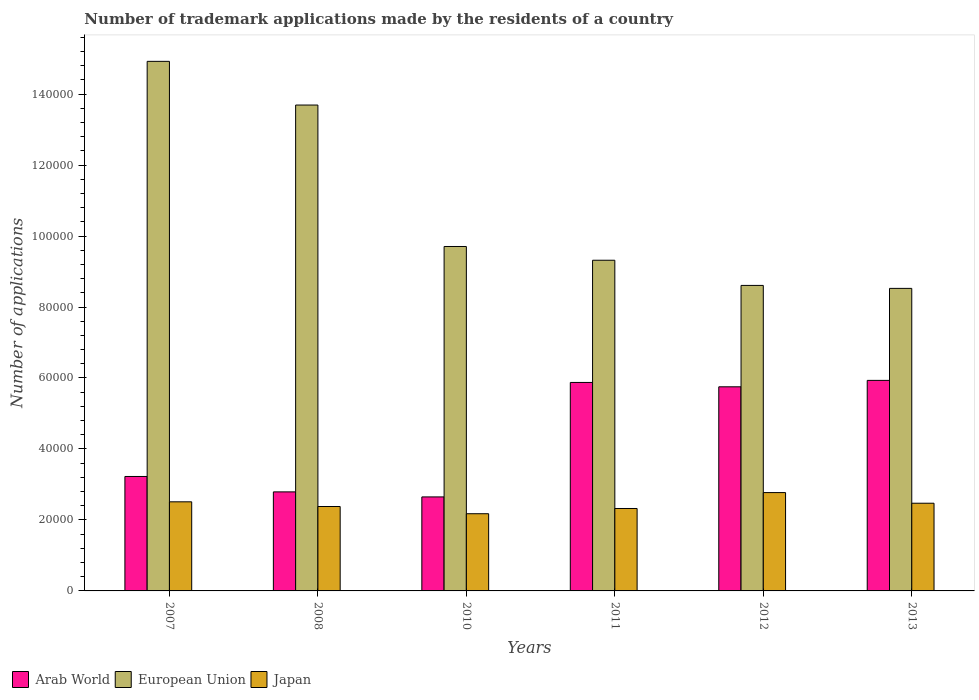How many different coloured bars are there?
Offer a terse response. 3. Are the number of bars per tick equal to the number of legend labels?
Provide a short and direct response. Yes. Are the number of bars on each tick of the X-axis equal?
Give a very brief answer. Yes. What is the label of the 3rd group of bars from the left?
Provide a short and direct response. 2010. What is the number of trademark applications made by the residents in European Union in 2012?
Your response must be concise. 8.61e+04. Across all years, what is the maximum number of trademark applications made by the residents in Arab World?
Your response must be concise. 5.93e+04. Across all years, what is the minimum number of trademark applications made by the residents in Japan?
Provide a succinct answer. 2.18e+04. In which year was the number of trademark applications made by the residents in European Union minimum?
Ensure brevity in your answer.  2013. What is the total number of trademark applications made by the residents in Arab World in the graph?
Offer a terse response. 2.62e+05. What is the difference between the number of trademark applications made by the residents in European Union in 2008 and that in 2011?
Give a very brief answer. 4.37e+04. What is the difference between the number of trademark applications made by the residents in Japan in 2010 and the number of trademark applications made by the residents in European Union in 2012?
Your response must be concise. -6.43e+04. What is the average number of trademark applications made by the residents in Japan per year?
Your answer should be compact. 2.44e+04. In the year 2007, what is the difference between the number of trademark applications made by the residents in Japan and number of trademark applications made by the residents in European Union?
Offer a very short reply. -1.24e+05. What is the ratio of the number of trademark applications made by the residents in Arab World in 2008 to that in 2010?
Offer a very short reply. 1.05. Is the number of trademark applications made by the residents in Japan in 2011 less than that in 2012?
Your answer should be very brief. Yes. What is the difference between the highest and the second highest number of trademark applications made by the residents in Arab World?
Your response must be concise. 583. What is the difference between the highest and the lowest number of trademark applications made by the residents in Arab World?
Provide a succinct answer. 3.28e+04. In how many years, is the number of trademark applications made by the residents in Japan greater than the average number of trademark applications made by the residents in Japan taken over all years?
Give a very brief answer. 3. Is the sum of the number of trademark applications made by the residents in Japan in 2008 and 2010 greater than the maximum number of trademark applications made by the residents in Arab World across all years?
Ensure brevity in your answer.  No. What does the 2nd bar from the left in 2010 represents?
Provide a succinct answer. European Union. Is it the case that in every year, the sum of the number of trademark applications made by the residents in Japan and number of trademark applications made by the residents in European Union is greater than the number of trademark applications made by the residents in Arab World?
Offer a terse response. Yes. Are all the bars in the graph horizontal?
Your response must be concise. No. How many years are there in the graph?
Your answer should be very brief. 6. How many legend labels are there?
Ensure brevity in your answer.  3. What is the title of the graph?
Your response must be concise. Number of trademark applications made by the residents of a country. Does "Macedonia" appear as one of the legend labels in the graph?
Your answer should be compact. No. What is the label or title of the Y-axis?
Provide a short and direct response. Number of applications. What is the Number of applications of Arab World in 2007?
Your response must be concise. 3.22e+04. What is the Number of applications in European Union in 2007?
Keep it short and to the point. 1.49e+05. What is the Number of applications in Japan in 2007?
Offer a terse response. 2.51e+04. What is the Number of applications of Arab World in 2008?
Give a very brief answer. 2.79e+04. What is the Number of applications in European Union in 2008?
Your answer should be very brief. 1.37e+05. What is the Number of applications of Japan in 2008?
Provide a succinct answer. 2.38e+04. What is the Number of applications in Arab World in 2010?
Ensure brevity in your answer.  2.65e+04. What is the Number of applications in European Union in 2010?
Your answer should be compact. 9.71e+04. What is the Number of applications of Japan in 2010?
Offer a terse response. 2.18e+04. What is the Number of applications in Arab World in 2011?
Give a very brief answer. 5.87e+04. What is the Number of applications in European Union in 2011?
Provide a short and direct response. 9.32e+04. What is the Number of applications of Japan in 2011?
Make the answer very short. 2.32e+04. What is the Number of applications of Arab World in 2012?
Give a very brief answer. 5.75e+04. What is the Number of applications in European Union in 2012?
Ensure brevity in your answer.  8.61e+04. What is the Number of applications in Japan in 2012?
Make the answer very short. 2.77e+04. What is the Number of applications in Arab World in 2013?
Your answer should be compact. 5.93e+04. What is the Number of applications of European Union in 2013?
Provide a short and direct response. 8.53e+04. What is the Number of applications of Japan in 2013?
Offer a very short reply. 2.47e+04. Across all years, what is the maximum Number of applications of Arab World?
Provide a short and direct response. 5.93e+04. Across all years, what is the maximum Number of applications of European Union?
Make the answer very short. 1.49e+05. Across all years, what is the maximum Number of applications in Japan?
Ensure brevity in your answer.  2.77e+04. Across all years, what is the minimum Number of applications of Arab World?
Give a very brief answer. 2.65e+04. Across all years, what is the minimum Number of applications in European Union?
Provide a succinct answer. 8.53e+04. Across all years, what is the minimum Number of applications in Japan?
Give a very brief answer. 2.18e+04. What is the total Number of applications in Arab World in the graph?
Your response must be concise. 2.62e+05. What is the total Number of applications of European Union in the graph?
Ensure brevity in your answer.  6.48e+05. What is the total Number of applications of Japan in the graph?
Your answer should be compact. 1.46e+05. What is the difference between the Number of applications of Arab World in 2007 and that in 2008?
Give a very brief answer. 4341. What is the difference between the Number of applications of European Union in 2007 and that in 2008?
Your answer should be very brief. 1.23e+04. What is the difference between the Number of applications in Japan in 2007 and that in 2008?
Offer a very short reply. 1318. What is the difference between the Number of applications of Arab World in 2007 and that in 2010?
Ensure brevity in your answer.  5757. What is the difference between the Number of applications of European Union in 2007 and that in 2010?
Your response must be concise. 5.22e+04. What is the difference between the Number of applications of Japan in 2007 and that in 2010?
Ensure brevity in your answer.  3356. What is the difference between the Number of applications in Arab World in 2007 and that in 2011?
Provide a short and direct response. -2.65e+04. What is the difference between the Number of applications of European Union in 2007 and that in 2011?
Your response must be concise. 5.60e+04. What is the difference between the Number of applications of Japan in 2007 and that in 2011?
Provide a succinct answer. 1879. What is the difference between the Number of applications of Arab World in 2007 and that in 2012?
Provide a succinct answer. -2.53e+04. What is the difference between the Number of applications of European Union in 2007 and that in 2012?
Provide a succinct answer. 6.31e+04. What is the difference between the Number of applications of Japan in 2007 and that in 2012?
Provide a succinct answer. -2601. What is the difference between the Number of applications of Arab World in 2007 and that in 2013?
Keep it short and to the point. -2.71e+04. What is the difference between the Number of applications in European Union in 2007 and that in 2013?
Your answer should be very brief. 6.40e+04. What is the difference between the Number of applications of Japan in 2007 and that in 2013?
Give a very brief answer. 394. What is the difference between the Number of applications in Arab World in 2008 and that in 2010?
Keep it short and to the point. 1416. What is the difference between the Number of applications in European Union in 2008 and that in 2010?
Give a very brief answer. 3.99e+04. What is the difference between the Number of applications of Japan in 2008 and that in 2010?
Make the answer very short. 2038. What is the difference between the Number of applications in Arab World in 2008 and that in 2011?
Your answer should be very brief. -3.08e+04. What is the difference between the Number of applications of European Union in 2008 and that in 2011?
Your response must be concise. 4.37e+04. What is the difference between the Number of applications of Japan in 2008 and that in 2011?
Your answer should be compact. 561. What is the difference between the Number of applications of Arab World in 2008 and that in 2012?
Ensure brevity in your answer.  -2.96e+04. What is the difference between the Number of applications of European Union in 2008 and that in 2012?
Offer a very short reply. 5.08e+04. What is the difference between the Number of applications of Japan in 2008 and that in 2012?
Provide a succinct answer. -3919. What is the difference between the Number of applications in Arab World in 2008 and that in 2013?
Your response must be concise. -3.14e+04. What is the difference between the Number of applications in European Union in 2008 and that in 2013?
Ensure brevity in your answer.  5.17e+04. What is the difference between the Number of applications in Japan in 2008 and that in 2013?
Provide a short and direct response. -924. What is the difference between the Number of applications in Arab World in 2010 and that in 2011?
Your answer should be compact. -3.23e+04. What is the difference between the Number of applications of European Union in 2010 and that in 2011?
Your answer should be compact. 3876. What is the difference between the Number of applications of Japan in 2010 and that in 2011?
Your answer should be very brief. -1477. What is the difference between the Number of applications of Arab World in 2010 and that in 2012?
Your answer should be very brief. -3.10e+04. What is the difference between the Number of applications in European Union in 2010 and that in 2012?
Give a very brief answer. 1.10e+04. What is the difference between the Number of applications in Japan in 2010 and that in 2012?
Ensure brevity in your answer.  -5957. What is the difference between the Number of applications in Arab World in 2010 and that in 2013?
Offer a very short reply. -3.28e+04. What is the difference between the Number of applications of European Union in 2010 and that in 2013?
Ensure brevity in your answer.  1.18e+04. What is the difference between the Number of applications of Japan in 2010 and that in 2013?
Provide a short and direct response. -2962. What is the difference between the Number of applications in Arab World in 2011 and that in 2012?
Ensure brevity in your answer.  1225. What is the difference between the Number of applications of European Union in 2011 and that in 2012?
Provide a short and direct response. 7090. What is the difference between the Number of applications in Japan in 2011 and that in 2012?
Ensure brevity in your answer.  -4480. What is the difference between the Number of applications in Arab World in 2011 and that in 2013?
Your answer should be compact. -583. What is the difference between the Number of applications in European Union in 2011 and that in 2013?
Your answer should be very brief. 7926. What is the difference between the Number of applications of Japan in 2011 and that in 2013?
Keep it short and to the point. -1485. What is the difference between the Number of applications in Arab World in 2012 and that in 2013?
Provide a succinct answer. -1808. What is the difference between the Number of applications of European Union in 2012 and that in 2013?
Your answer should be very brief. 836. What is the difference between the Number of applications in Japan in 2012 and that in 2013?
Ensure brevity in your answer.  2995. What is the difference between the Number of applications of Arab World in 2007 and the Number of applications of European Union in 2008?
Offer a terse response. -1.05e+05. What is the difference between the Number of applications of Arab World in 2007 and the Number of applications of Japan in 2008?
Provide a short and direct response. 8460. What is the difference between the Number of applications in European Union in 2007 and the Number of applications in Japan in 2008?
Keep it short and to the point. 1.25e+05. What is the difference between the Number of applications of Arab World in 2007 and the Number of applications of European Union in 2010?
Offer a very short reply. -6.48e+04. What is the difference between the Number of applications in Arab World in 2007 and the Number of applications in Japan in 2010?
Provide a succinct answer. 1.05e+04. What is the difference between the Number of applications of European Union in 2007 and the Number of applications of Japan in 2010?
Offer a very short reply. 1.27e+05. What is the difference between the Number of applications in Arab World in 2007 and the Number of applications in European Union in 2011?
Your response must be concise. -6.09e+04. What is the difference between the Number of applications in Arab World in 2007 and the Number of applications in Japan in 2011?
Ensure brevity in your answer.  9021. What is the difference between the Number of applications of European Union in 2007 and the Number of applications of Japan in 2011?
Provide a short and direct response. 1.26e+05. What is the difference between the Number of applications in Arab World in 2007 and the Number of applications in European Union in 2012?
Offer a terse response. -5.38e+04. What is the difference between the Number of applications of Arab World in 2007 and the Number of applications of Japan in 2012?
Your response must be concise. 4541. What is the difference between the Number of applications of European Union in 2007 and the Number of applications of Japan in 2012?
Make the answer very short. 1.22e+05. What is the difference between the Number of applications of Arab World in 2007 and the Number of applications of European Union in 2013?
Your answer should be very brief. -5.30e+04. What is the difference between the Number of applications in Arab World in 2007 and the Number of applications in Japan in 2013?
Your answer should be compact. 7536. What is the difference between the Number of applications of European Union in 2007 and the Number of applications of Japan in 2013?
Offer a very short reply. 1.25e+05. What is the difference between the Number of applications of Arab World in 2008 and the Number of applications of European Union in 2010?
Your response must be concise. -6.91e+04. What is the difference between the Number of applications of Arab World in 2008 and the Number of applications of Japan in 2010?
Provide a short and direct response. 6157. What is the difference between the Number of applications in European Union in 2008 and the Number of applications in Japan in 2010?
Give a very brief answer. 1.15e+05. What is the difference between the Number of applications of Arab World in 2008 and the Number of applications of European Union in 2011?
Your answer should be very brief. -6.53e+04. What is the difference between the Number of applications in Arab World in 2008 and the Number of applications in Japan in 2011?
Ensure brevity in your answer.  4680. What is the difference between the Number of applications in European Union in 2008 and the Number of applications in Japan in 2011?
Provide a short and direct response. 1.14e+05. What is the difference between the Number of applications of Arab World in 2008 and the Number of applications of European Union in 2012?
Give a very brief answer. -5.82e+04. What is the difference between the Number of applications of European Union in 2008 and the Number of applications of Japan in 2012?
Provide a succinct answer. 1.09e+05. What is the difference between the Number of applications in Arab World in 2008 and the Number of applications in European Union in 2013?
Your answer should be very brief. -5.73e+04. What is the difference between the Number of applications of Arab World in 2008 and the Number of applications of Japan in 2013?
Make the answer very short. 3195. What is the difference between the Number of applications of European Union in 2008 and the Number of applications of Japan in 2013?
Ensure brevity in your answer.  1.12e+05. What is the difference between the Number of applications of Arab World in 2010 and the Number of applications of European Union in 2011?
Provide a succinct answer. -6.67e+04. What is the difference between the Number of applications in Arab World in 2010 and the Number of applications in Japan in 2011?
Your answer should be compact. 3264. What is the difference between the Number of applications of European Union in 2010 and the Number of applications of Japan in 2011?
Offer a terse response. 7.38e+04. What is the difference between the Number of applications in Arab World in 2010 and the Number of applications in European Union in 2012?
Give a very brief answer. -5.96e+04. What is the difference between the Number of applications of Arab World in 2010 and the Number of applications of Japan in 2012?
Provide a succinct answer. -1216. What is the difference between the Number of applications in European Union in 2010 and the Number of applications in Japan in 2012?
Give a very brief answer. 6.93e+04. What is the difference between the Number of applications in Arab World in 2010 and the Number of applications in European Union in 2013?
Ensure brevity in your answer.  -5.88e+04. What is the difference between the Number of applications in Arab World in 2010 and the Number of applications in Japan in 2013?
Give a very brief answer. 1779. What is the difference between the Number of applications in European Union in 2010 and the Number of applications in Japan in 2013?
Offer a terse response. 7.23e+04. What is the difference between the Number of applications in Arab World in 2011 and the Number of applications in European Union in 2012?
Offer a terse response. -2.73e+04. What is the difference between the Number of applications in Arab World in 2011 and the Number of applications in Japan in 2012?
Offer a terse response. 3.10e+04. What is the difference between the Number of applications of European Union in 2011 and the Number of applications of Japan in 2012?
Keep it short and to the point. 6.55e+04. What is the difference between the Number of applications of Arab World in 2011 and the Number of applications of European Union in 2013?
Give a very brief answer. -2.65e+04. What is the difference between the Number of applications of Arab World in 2011 and the Number of applications of Japan in 2013?
Make the answer very short. 3.40e+04. What is the difference between the Number of applications in European Union in 2011 and the Number of applications in Japan in 2013?
Provide a short and direct response. 6.85e+04. What is the difference between the Number of applications of Arab World in 2012 and the Number of applications of European Union in 2013?
Make the answer very short. -2.77e+04. What is the difference between the Number of applications of Arab World in 2012 and the Number of applications of Japan in 2013?
Provide a succinct answer. 3.28e+04. What is the difference between the Number of applications in European Union in 2012 and the Number of applications in Japan in 2013?
Provide a short and direct response. 6.14e+04. What is the average Number of applications in Arab World per year?
Your response must be concise. 4.37e+04. What is the average Number of applications of European Union per year?
Give a very brief answer. 1.08e+05. What is the average Number of applications in Japan per year?
Your answer should be compact. 2.44e+04. In the year 2007, what is the difference between the Number of applications in Arab World and Number of applications in European Union?
Your response must be concise. -1.17e+05. In the year 2007, what is the difference between the Number of applications of Arab World and Number of applications of Japan?
Offer a terse response. 7142. In the year 2007, what is the difference between the Number of applications in European Union and Number of applications in Japan?
Keep it short and to the point. 1.24e+05. In the year 2008, what is the difference between the Number of applications of Arab World and Number of applications of European Union?
Offer a terse response. -1.09e+05. In the year 2008, what is the difference between the Number of applications of Arab World and Number of applications of Japan?
Provide a succinct answer. 4119. In the year 2008, what is the difference between the Number of applications of European Union and Number of applications of Japan?
Provide a succinct answer. 1.13e+05. In the year 2010, what is the difference between the Number of applications of Arab World and Number of applications of European Union?
Give a very brief answer. -7.06e+04. In the year 2010, what is the difference between the Number of applications of Arab World and Number of applications of Japan?
Your answer should be compact. 4741. In the year 2010, what is the difference between the Number of applications of European Union and Number of applications of Japan?
Make the answer very short. 7.53e+04. In the year 2011, what is the difference between the Number of applications of Arab World and Number of applications of European Union?
Provide a short and direct response. -3.44e+04. In the year 2011, what is the difference between the Number of applications of Arab World and Number of applications of Japan?
Provide a short and direct response. 3.55e+04. In the year 2011, what is the difference between the Number of applications in European Union and Number of applications in Japan?
Your response must be concise. 7.00e+04. In the year 2012, what is the difference between the Number of applications in Arab World and Number of applications in European Union?
Make the answer very short. -2.86e+04. In the year 2012, what is the difference between the Number of applications of Arab World and Number of applications of Japan?
Keep it short and to the point. 2.98e+04. In the year 2012, what is the difference between the Number of applications in European Union and Number of applications in Japan?
Offer a very short reply. 5.84e+04. In the year 2013, what is the difference between the Number of applications of Arab World and Number of applications of European Union?
Your answer should be very brief. -2.59e+04. In the year 2013, what is the difference between the Number of applications in Arab World and Number of applications in Japan?
Provide a short and direct response. 3.46e+04. In the year 2013, what is the difference between the Number of applications of European Union and Number of applications of Japan?
Give a very brief answer. 6.05e+04. What is the ratio of the Number of applications of Arab World in 2007 to that in 2008?
Ensure brevity in your answer.  1.16. What is the ratio of the Number of applications of European Union in 2007 to that in 2008?
Provide a short and direct response. 1.09. What is the ratio of the Number of applications of Japan in 2007 to that in 2008?
Offer a terse response. 1.06. What is the ratio of the Number of applications of Arab World in 2007 to that in 2010?
Ensure brevity in your answer.  1.22. What is the ratio of the Number of applications of European Union in 2007 to that in 2010?
Your answer should be very brief. 1.54. What is the ratio of the Number of applications of Japan in 2007 to that in 2010?
Offer a very short reply. 1.15. What is the ratio of the Number of applications in Arab World in 2007 to that in 2011?
Offer a terse response. 0.55. What is the ratio of the Number of applications in European Union in 2007 to that in 2011?
Your answer should be compact. 1.6. What is the ratio of the Number of applications of Japan in 2007 to that in 2011?
Your answer should be compact. 1.08. What is the ratio of the Number of applications in Arab World in 2007 to that in 2012?
Your answer should be very brief. 0.56. What is the ratio of the Number of applications in European Union in 2007 to that in 2012?
Your answer should be very brief. 1.73. What is the ratio of the Number of applications of Japan in 2007 to that in 2012?
Your response must be concise. 0.91. What is the ratio of the Number of applications of Arab World in 2007 to that in 2013?
Ensure brevity in your answer.  0.54. What is the ratio of the Number of applications of European Union in 2007 to that in 2013?
Make the answer very short. 1.75. What is the ratio of the Number of applications in Japan in 2007 to that in 2013?
Provide a short and direct response. 1.02. What is the ratio of the Number of applications in Arab World in 2008 to that in 2010?
Ensure brevity in your answer.  1.05. What is the ratio of the Number of applications in European Union in 2008 to that in 2010?
Your answer should be very brief. 1.41. What is the ratio of the Number of applications of Japan in 2008 to that in 2010?
Keep it short and to the point. 1.09. What is the ratio of the Number of applications in Arab World in 2008 to that in 2011?
Ensure brevity in your answer.  0.48. What is the ratio of the Number of applications in European Union in 2008 to that in 2011?
Keep it short and to the point. 1.47. What is the ratio of the Number of applications in Japan in 2008 to that in 2011?
Make the answer very short. 1.02. What is the ratio of the Number of applications in Arab World in 2008 to that in 2012?
Keep it short and to the point. 0.49. What is the ratio of the Number of applications in European Union in 2008 to that in 2012?
Make the answer very short. 1.59. What is the ratio of the Number of applications in Japan in 2008 to that in 2012?
Offer a very short reply. 0.86. What is the ratio of the Number of applications in Arab World in 2008 to that in 2013?
Make the answer very short. 0.47. What is the ratio of the Number of applications of European Union in 2008 to that in 2013?
Your answer should be compact. 1.61. What is the ratio of the Number of applications of Japan in 2008 to that in 2013?
Offer a very short reply. 0.96. What is the ratio of the Number of applications in Arab World in 2010 to that in 2011?
Offer a terse response. 0.45. What is the ratio of the Number of applications of European Union in 2010 to that in 2011?
Offer a very short reply. 1.04. What is the ratio of the Number of applications of Japan in 2010 to that in 2011?
Keep it short and to the point. 0.94. What is the ratio of the Number of applications in Arab World in 2010 to that in 2012?
Your answer should be compact. 0.46. What is the ratio of the Number of applications in European Union in 2010 to that in 2012?
Provide a short and direct response. 1.13. What is the ratio of the Number of applications in Japan in 2010 to that in 2012?
Ensure brevity in your answer.  0.79. What is the ratio of the Number of applications of Arab World in 2010 to that in 2013?
Your response must be concise. 0.45. What is the ratio of the Number of applications in European Union in 2010 to that in 2013?
Provide a short and direct response. 1.14. What is the ratio of the Number of applications in Japan in 2010 to that in 2013?
Offer a very short reply. 0.88. What is the ratio of the Number of applications in Arab World in 2011 to that in 2012?
Provide a short and direct response. 1.02. What is the ratio of the Number of applications in European Union in 2011 to that in 2012?
Make the answer very short. 1.08. What is the ratio of the Number of applications of Japan in 2011 to that in 2012?
Ensure brevity in your answer.  0.84. What is the ratio of the Number of applications in Arab World in 2011 to that in 2013?
Give a very brief answer. 0.99. What is the ratio of the Number of applications of European Union in 2011 to that in 2013?
Provide a succinct answer. 1.09. What is the ratio of the Number of applications of Japan in 2011 to that in 2013?
Offer a very short reply. 0.94. What is the ratio of the Number of applications of Arab World in 2012 to that in 2013?
Provide a succinct answer. 0.97. What is the ratio of the Number of applications in European Union in 2012 to that in 2013?
Keep it short and to the point. 1.01. What is the ratio of the Number of applications of Japan in 2012 to that in 2013?
Make the answer very short. 1.12. What is the difference between the highest and the second highest Number of applications in Arab World?
Ensure brevity in your answer.  583. What is the difference between the highest and the second highest Number of applications in European Union?
Offer a very short reply. 1.23e+04. What is the difference between the highest and the second highest Number of applications in Japan?
Provide a succinct answer. 2601. What is the difference between the highest and the lowest Number of applications in Arab World?
Keep it short and to the point. 3.28e+04. What is the difference between the highest and the lowest Number of applications of European Union?
Make the answer very short. 6.40e+04. What is the difference between the highest and the lowest Number of applications of Japan?
Keep it short and to the point. 5957. 